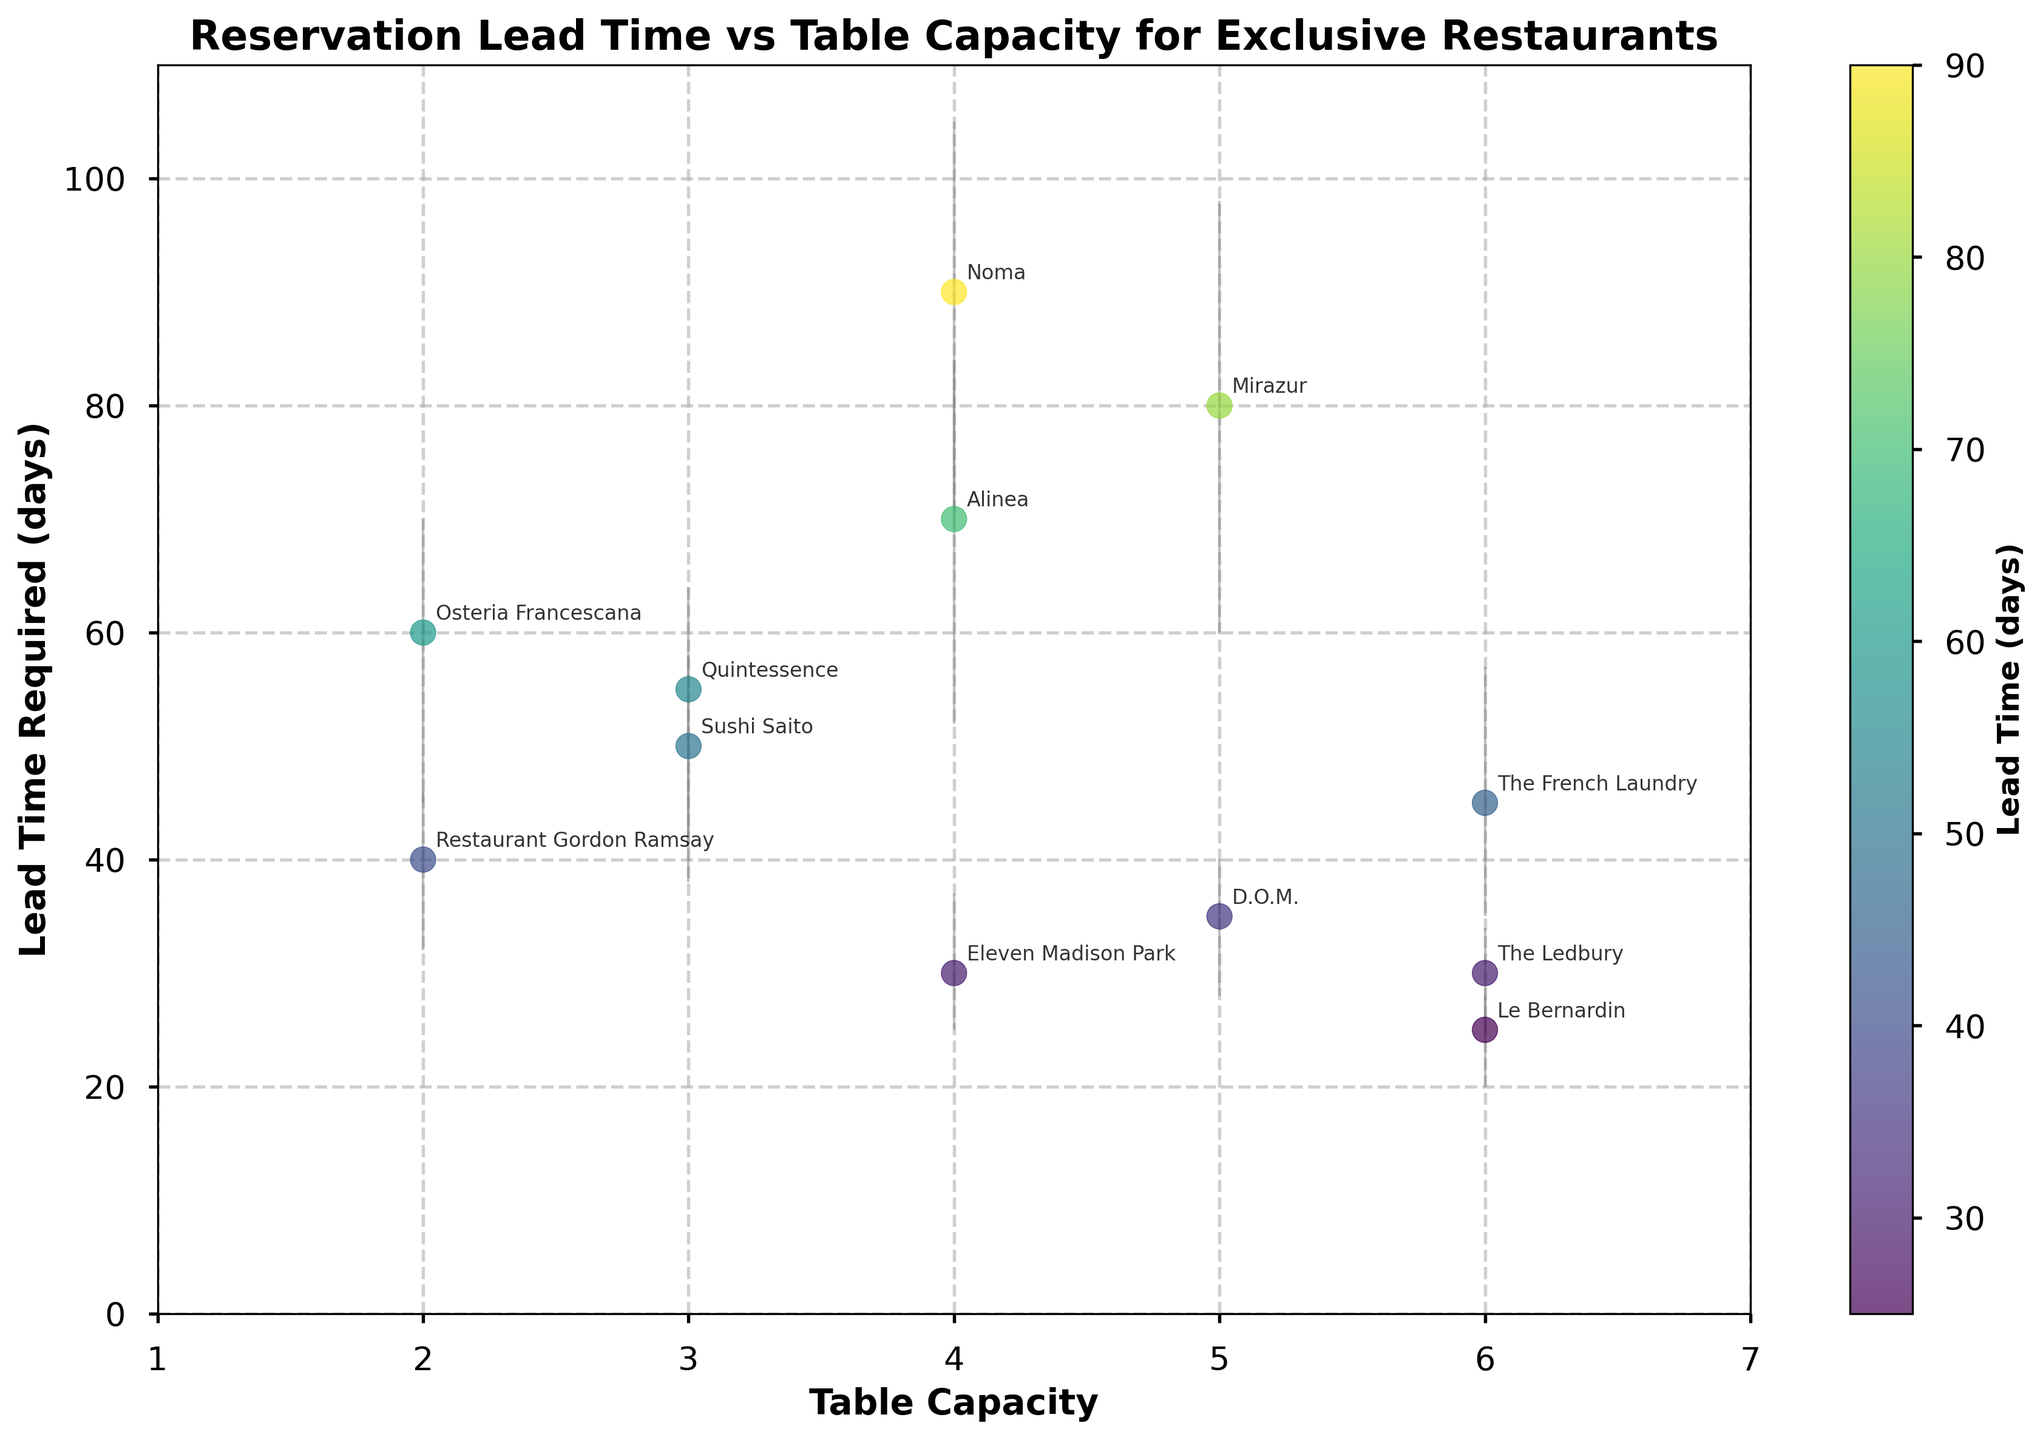What's the title of the scatter plot? The title is located at the top of the plot and provides a summary of what the plot is about.
Answer: Reservation Lead Time vs Table Capacity for Exclusive Restaurants What is the range of table capacities shown in the plot? The x-axis shows table capacities ranging from the smallest to the largest values.
Answer: 1 to 6 Which restaurant requires the longest lead time for reservations? The restaurant point that is the highest on the y-axis represents the longest lead time.
Answer: Noma What are the minimum and maximum errors for the lead time at Eleven Madison Park? Eleven Madison Park's data point will have error bars extending above and below the point showing the range of the lead time.
Answer: 5 and 7 days How does the lead time required for reservations at The French Laundry compare to that at Le Bernardin? The data points can be compared by locating them on the plot and comparing their y-values, representing lead times.
Answer: Higher at The French Laundry (45 days) compared to Le Bernardin (25 days) Which restaurant with a table capacity of 5 requires the highest lead time for reservations? Identify all data points with x=5, then note the y-value (lead time) for each and find the highest one.
Answer: Mirazur (80 days) What is the average lead time for restaurants with a table capacity of 4? Find all data points with x=4 and calculate the average of their y-values. (Lead times are 30, 90, and 70 days)
Answer: (30 + 90 + 70) / 3 = 63.3 days Which restaurant has the smallest lead time required for reservations? The restaurant point that is the lowest on the y-axis represents the smallest lead time.
Answer: Le Bernardin (25 days) What are the error bar values for Sushi Saito's lead time? Find Sushi Saito's data point and read the lengths of error bars above and below the point indicating the range of lead times.
Answer: 12 and 8 days Between Osteria Francescana and Restaurant Gordon Ramsay, which has a larger range of required lead times and how much larger is it? Calculate the range (max error + min error) for both restaurants and compare the differences.
Answer: Osteria Francescana (25 days) has a larger range than Restaurant Gordon Ramsay (14 days). It is 11 days larger 